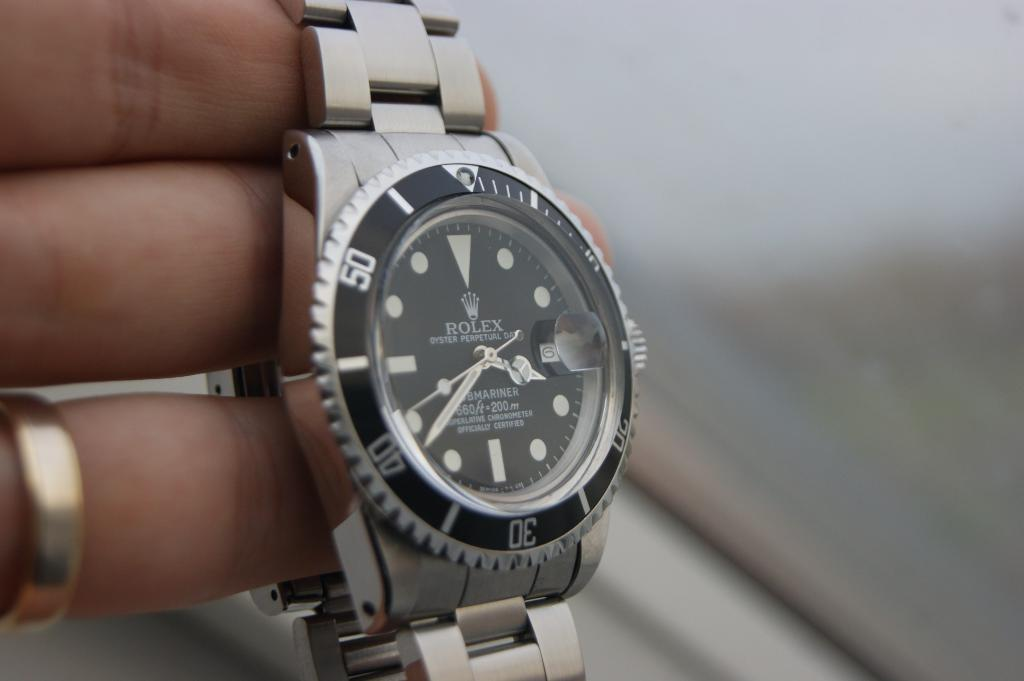Provide a one-sentence caption for the provided image. Someone wearing a wedding band holds a Rolex watch. 